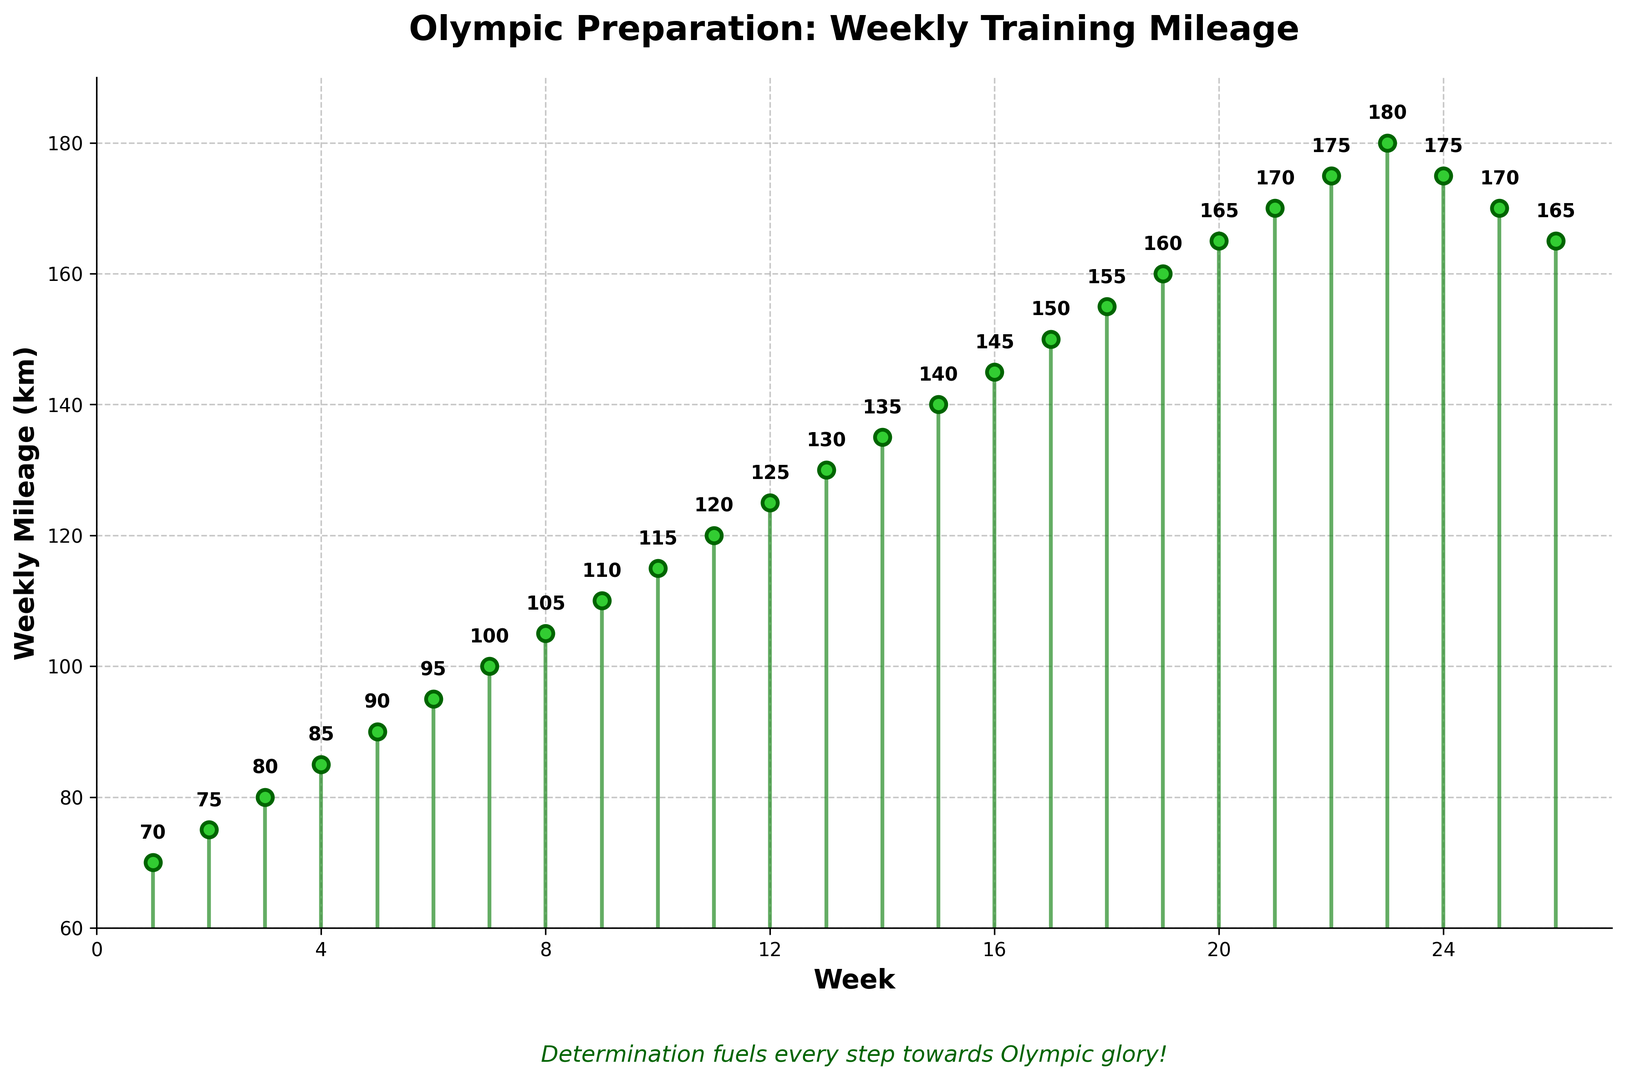What is the overall trend of the weekly mileage over the 26-week period? The weekly mileage starts at 70 km and generally increases until it reaches a peak at week 23 with 180 km, after which it gradually declines back to 165 km by week 26.
Answer: Increasing trend followed by a decline When does the weekly mileage first reach 150 km? Looking at the x-axis for the week and the y-axis for mileage, the weekly mileage first reaches 150 km at week 17.
Answer: Week 17 Which week has the highest mileage and what is the mileage? Observing the highest point on the y-axis and checking the corresponding week on the x-axis, the highest mileage of 180 km occurs in week 23.
Answer: Week 23, 180 km What is the difference in mileage between week 10 and week 20? Week 10 has 115 km and week 20 has 165 km. Subtract the mileage of week 10 from that of week 20 (165 - 115).
Answer: 50 km How many weeks have a mileage of 175 km? Observing the y-axis for 175 km and counting the corresponding weeks on the x-axis, there are two weeks with 175 km (weeks 22 and 24).
Answer: 2 weeks Between which weeks does the mileage quickly increase the most? Comparing the slopes between consecutive points, the greatest increase is observed between weeks 18 (155 km) and 19 (160 km), and weeks 22 (175 km) and 23 (180 km), where it increases by 5 km each week.
Answer: Weeks 18 to 19, and 22 to 23 How many weeks record a mileage greater than 150 km? Checking the y-axis for values greater than 150 km and counting the corresponding weeks on the x-axis, 10 weeks have a mileage greater than 150 km (weeks 17 to 26).
Answer: 10 weeks What is the average mileage for the first 6 weeks? Sum the mileage for the first 6 weeks (70 + 75 + 80 + 85 + 90 + 95) and divide by 6. The result is (495/6).
Answer: 82.5 km Which week marks the start of the decline in mileage after it peaks? Week 24 shows a decrease from week 23's mileage, indicating the start of the decline from the peak mileage.
Answer: Week 24 Visual question: What color represents the data points and lines, and how are they styled? The data points are lime green with a dark green edge, while the line segments connecting the points are forest green and slightly transparent.
Answer: Lime green points, forest green lines 